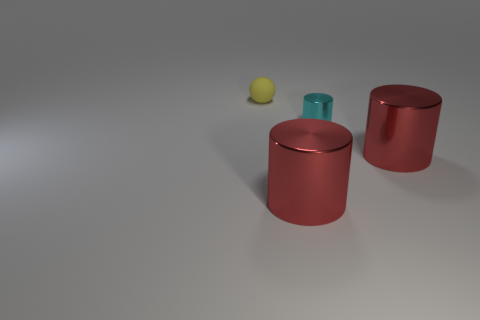Is the material of the cyan object the same as the yellow thing on the left side of the cyan shiny object?
Offer a terse response. No. There is a big thing that is left of the tiny cylinder that is behind the large red shiny cylinder that is to the left of the tiny metallic cylinder; what is its color?
Your response must be concise. Red. There is a rubber thing that is the same size as the cyan shiny thing; what shape is it?
Provide a short and direct response. Sphere. There is a object on the right side of the cyan metal object; is it the same size as the thing that is behind the tiny cyan cylinder?
Your answer should be compact. No. How big is the red object on the right side of the cyan thing?
Give a very brief answer. Large. There is a rubber object that is the same size as the cyan cylinder; what is its color?
Offer a terse response. Yellow. What is the size of the thing that is both to the left of the small cyan shiny thing and in front of the cyan metal cylinder?
Your response must be concise. Large. What number of metallic things are cyan spheres or tiny cyan things?
Ensure brevity in your answer.  1. Are there more large red cylinders that are in front of the small yellow sphere than small yellow matte objects?
Offer a very short reply. Yes. What is the material of the tiny object that is in front of the rubber sphere?
Give a very brief answer. Metal. 